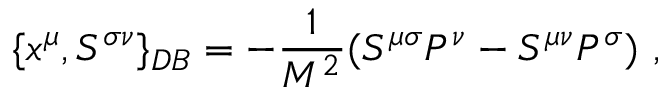Convert formula to latex. <formula><loc_0><loc_0><loc_500><loc_500>\{ x ^ { \mu } , S ^ { \sigma \nu } \} _ { D B } = - \frac { 1 } { M ^ { 2 } } ( S ^ { \mu \sigma } P ^ { \nu } - S ^ { \mu \nu } P ^ { \sigma } ) ,</formula> 